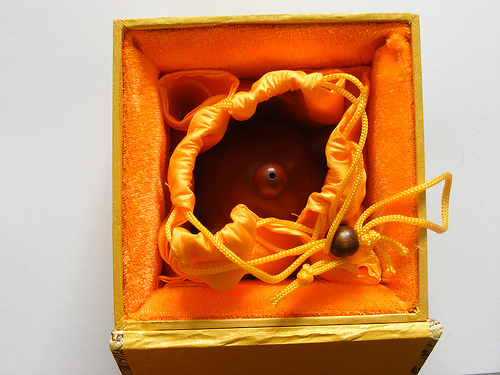<image>
Is the string under the bag? No. The string is not positioned under the bag. The vertical relationship between these objects is different. 